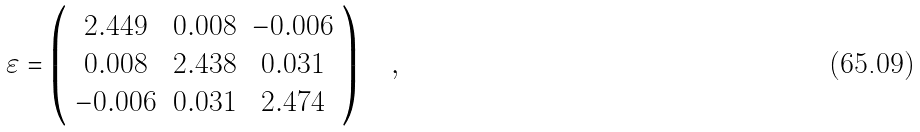Convert formula to latex. <formula><loc_0><loc_0><loc_500><loc_500>\varepsilon = \left ( \begin{array} { c c c } 2 . 4 4 9 & 0 . 0 0 8 & - 0 . 0 0 6 \\ 0 . 0 0 8 & 2 . 4 3 8 & 0 . 0 3 1 \\ - 0 . 0 0 6 & 0 . 0 3 1 & 2 . 4 7 4 \\ \end{array} \right ) \quad ,</formula> 